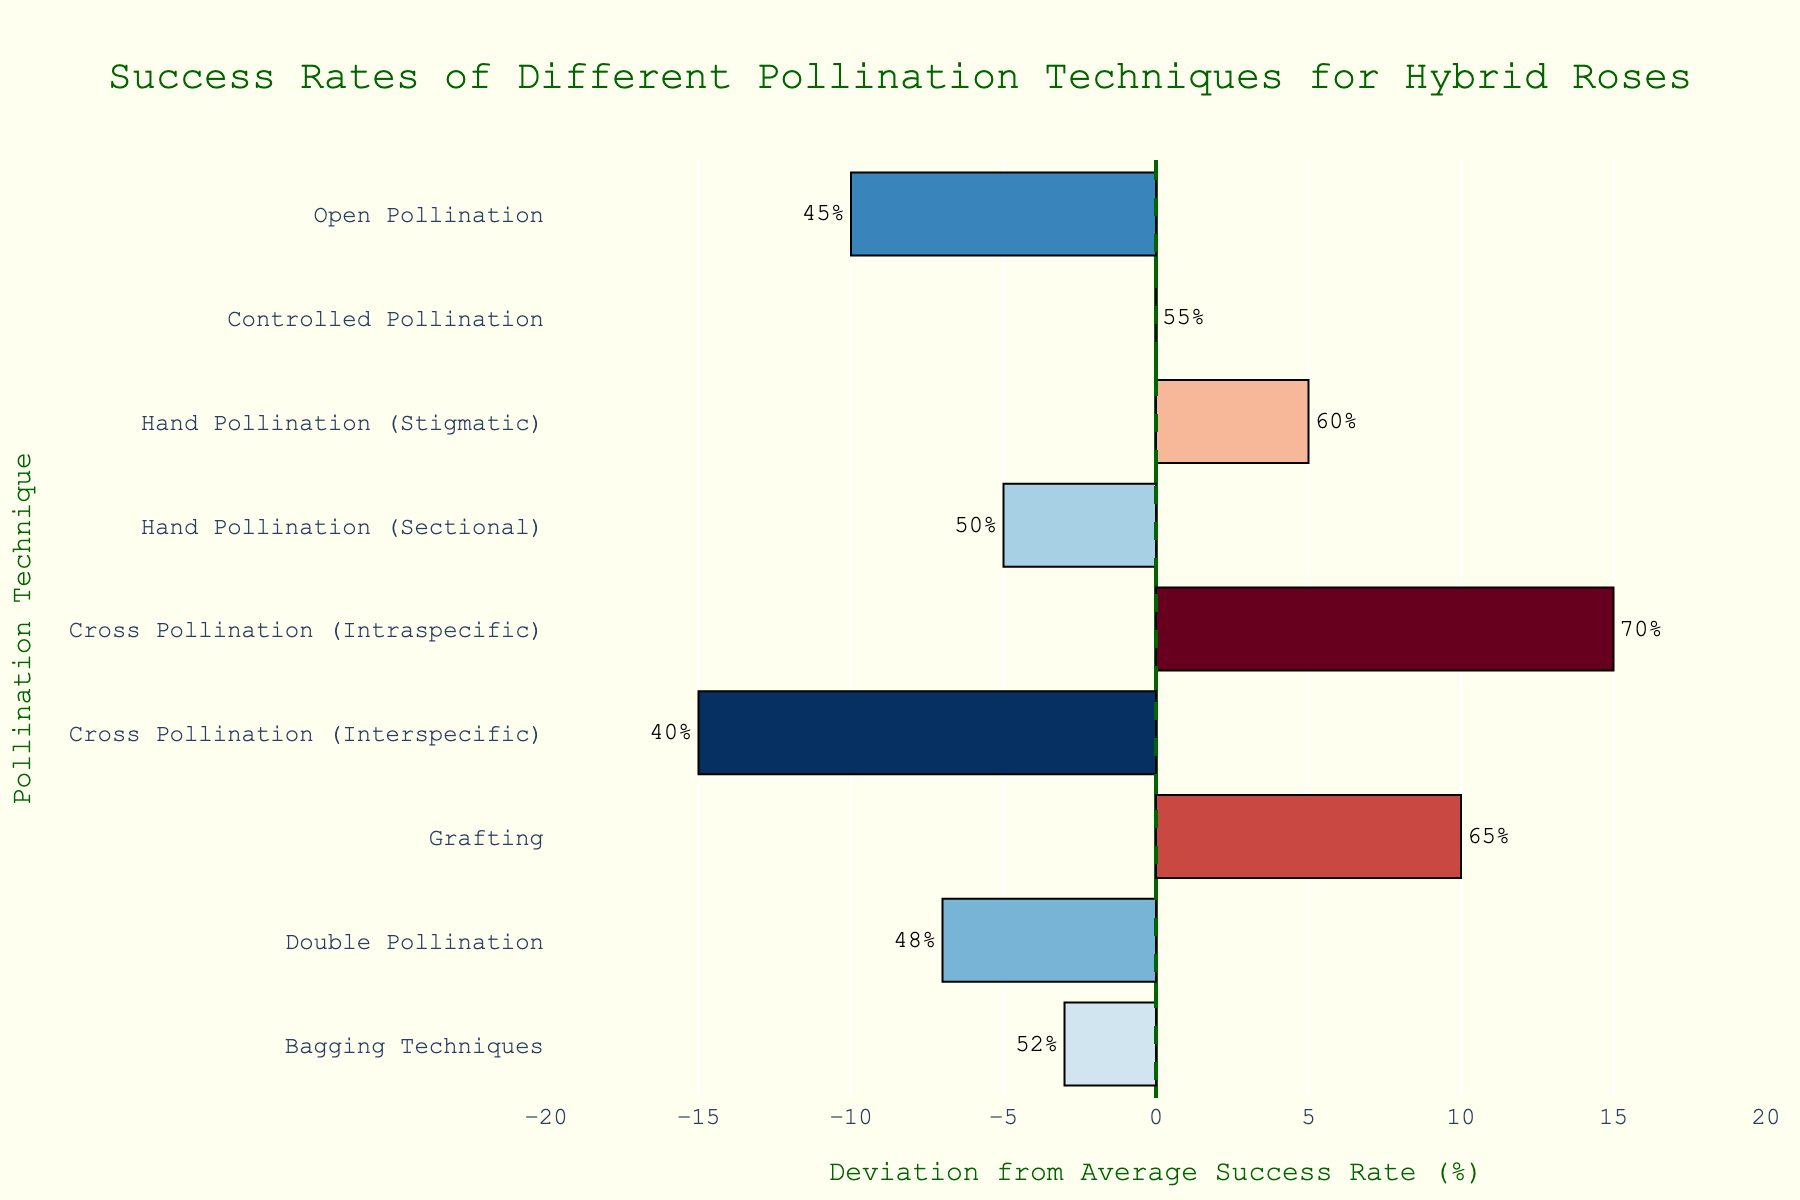Which pollination technique has the highest success rate? The bar that extends farthest to the right on the chart corresponds to "Cross Pollination (Intraspecific)," indicating that it has the highest success rate of 70%.
Answer: Cross Pollination (Intraspecific) Which pollination technique shows the largest deviation from the average success rate? The bar with the longest length, whether positive or negative, corresponds to "Cross Pollination (Intraspecific)" for positive deviation and "Cross Pollination (Interspecific)" for negative deviation, both having a deviation of ±15%.
Answer: Cross Pollination (Intraspecific) and Cross Pollination (Interspecific) What is the combined success rate for all hand pollination techniques? The success rates for "Hand Pollination (Stigmatic)" and "Hand Pollination (Sectional)" are 60% and 50% respectively. Summing them gives 60 + 50 = 110%.
Answer: 110% How much higher is the success rate of "Grafting" compared to "Open Pollination"? "Grafting" has a success rate of 65% and "Open Pollination" has a success rate of 45%. The difference is 65 - 45 = 20%.
Answer: 20% Which pollination technique is closest to the average success rate? The technique whose deviation is closest to 0 is "Controlled Pollination," with a deviation of 0.
Answer: Controlled Pollination Which pollination techniques have a success rate below 50%? Techniques represented by bars extending to the left and having values below the average (<= 50%) are "Open Pollination" (45%), "Hand Pollination (Sectional)" (50%), "Cross Pollination (Interspecific)" (40%), and "Double Pollination" (48%).
Answer: Open Pollination, Hand Pollination (Sectional), Cross Pollination (Interspecific), Double Pollination What is the visual representation for the average success rate on the chart? The average success rate is represented by a vertical dashed line that intersects the x-axis at 0, highlighted in dark green.
Answer: Vertical dashed line at 0 